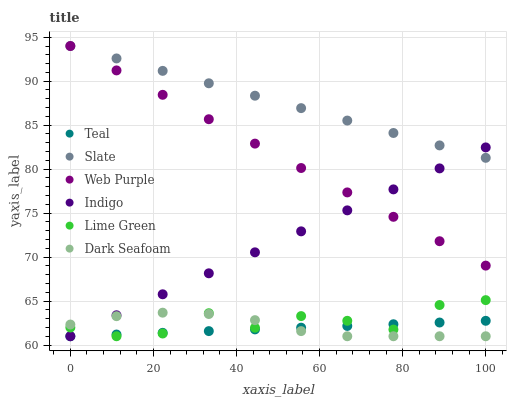Does Teal have the minimum area under the curve?
Answer yes or no. Yes. Does Slate have the maximum area under the curve?
Answer yes or no. Yes. Does Web Purple have the minimum area under the curve?
Answer yes or no. No. Does Web Purple have the maximum area under the curve?
Answer yes or no. No. Is Teal the smoothest?
Answer yes or no. Yes. Is Lime Green the roughest?
Answer yes or no. Yes. Is Slate the smoothest?
Answer yes or no. No. Is Slate the roughest?
Answer yes or no. No. Does Indigo have the lowest value?
Answer yes or no. Yes. Does Web Purple have the lowest value?
Answer yes or no. No. Does Web Purple have the highest value?
Answer yes or no. Yes. Does Dark Seafoam have the highest value?
Answer yes or no. No. Is Teal less than Slate?
Answer yes or no. Yes. Is Slate greater than Lime Green?
Answer yes or no. Yes. Does Teal intersect Indigo?
Answer yes or no. Yes. Is Teal less than Indigo?
Answer yes or no. No. Is Teal greater than Indigo?
Answer yes or no. No. Does Teal intersect Slate?
Answer yes or no. No. 